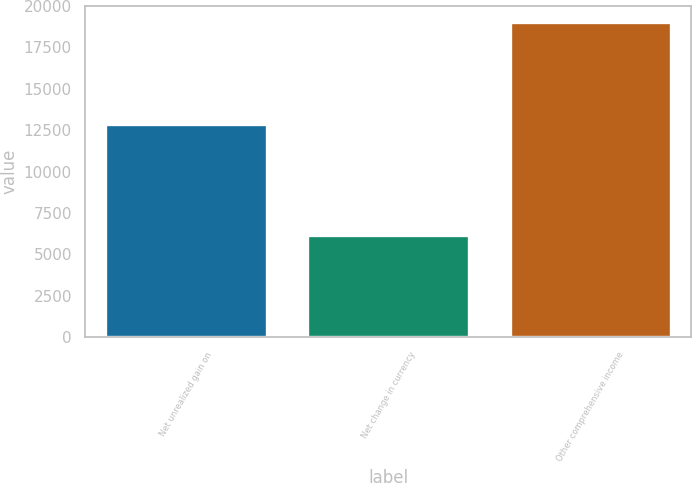Convert chart. <chart><loc_0><loc_0><loc_500><loc_500><bar_chart><fcel>Net unrealized gain on<fcel>Net change in currency<fcel>Other comprehensive income<nl><fcel>12886<fcel>6166<fcel>19052<nl></chart> 